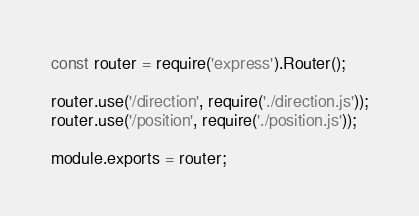<code> <loc_0><loc_0><loc_500><loc_500><_JavaScript_>const router = require('express').Router();

router.use('/direction', require('./direction.js'));
router.use('/position', require('./position.js'));

module.exports = router;
</code> 